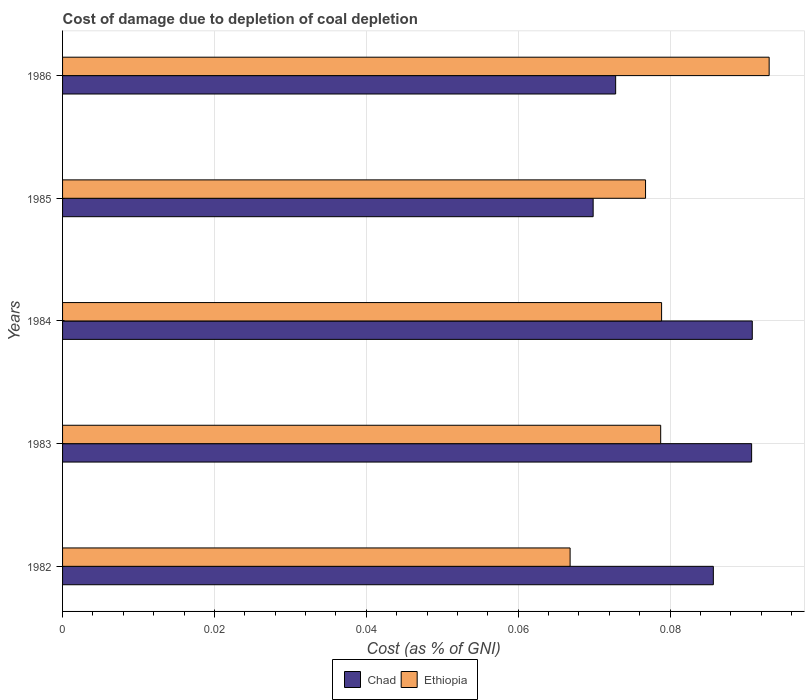How many groups of bars are there?
Keep it short and to the point. 5. Are the number of bars on each tick of the Y-axis equal?
Provide a short and direct response. Yes. How many bars are there on the 5th tick from the top?
Give a very brief answer. 2. How many bars are there on the 3rd tick from the bottom?
Provide a short and direct response. 2. In how many cases, is the number of bars for a given year not equal to the number of legend labels?
Ensure brevity in your answer.  0. What is the cost of damage caused due to coal depletion in Ethiopia in 1984?
Provide a succinct answer. 0.08. Across all years, what is the maximum cost of damage caused due to coal depletion in Ethiopia?
Ensure brevity in your answer.  0.09. Across all years, what is the minimum cost of damage caused due to coal depletion in Ethiopia?
Provide a short and direct response. 0.07. In which year was the cost of damage caused due to coal depletion in Ethiopia minimum?
Your answer should be compact. 1982. What is the total cost of damage caused due to coal depletion in Ethiopia in the graph?
Your response must be concise. 0.39. What is the difference between the cost of damage caused due to coal depletion in Chad in 1983 and that in 1985?
Ensure brevity in your answer.  0.02. What is the difference between the cost of damage caused due to coal depletion in Ethiopia in 1985 and the cost of damage caused due to coal depletion in Chad in 1983?
Offer a terse response. -0.01. What is the average cost of damage caused due to coal depletion in Ethiopia per year?
Offer a terse response. 0.08. In the year 1985, what is the difference between the cost of damage caused due to coal depletion in Ethiopia and cost of damage caused due to coal depletion in Chad?
Your answer should be very brief. 0.01. What is the ratio of the cost of damage caused due to coal depletion in Chad in 1983 to that in 1986?
Give a very brief answer. 1.25. Is the cost of damage caused due to coal depletion in Ethiopia in 1984 less than that in 1986?
Keep it short and to the point. Yes. What is the difference between the highest and the second highest cost of damage caused due to coal depletion in Ethiopia?
Offer a terse response. 0.01. What is the difference between the highest and the lowest cost of damage caused due to coal depletion in Ethiopia?
Make the answer very short. 0.03. In how many years, is the cost of damage caused due to coal depletion in Ethiopia greater than the average cost of damage caused due to coal depletion in Ethiopia taken over all years?
Give a very brief answer. 2. Is the sum of the cost of damage caused due to coal depletion in Ethiopia in 1983 and 1986 greater than the maximum cost of damage caused due to coal depletion in Chad across all years?
Ensure brevity in your answer.  Yes. What does the 1st bar from the top in 1983 represents?
Your response must be concise. Ethiopia. What does the 1st bar from the bottom in 1983 represents?
Keep it short and to the point. Chad. How many bars are there?
Offer a terse response. 10. Are all the bars in the graph horizontal?
Offer a terse response. Yes. What is the difference between two consecutive major ticks on the X-axis?
Provide a short and direct response. 0.02. Are the values on the major ticks of X-axis written in scientific E-notation?
Keep it short and to the point. No. Does the graph contain any zero values?
Ensure brevity in your answer.  No. What is the title of the graph?
Keep it short and to the point. Cost of damage due to depletion of coal depletion. Does "United Arab Emirates" appear as one of the legend labels in the graph?
Your response must be concise. No. What is the label or title of the X-axis?
Your answer should be very brief. Cost (as % of GNI). What is the Cost (as % of GNI) of Chad in 1982?
Your answer should be very brief. 0.09. What is the Cost (as % of GNI) in Ethiopia in 1982?
Give a very brief answer. 0.07. What is the Cost (as % of GNI) of Chad in 1983?
Your answer should be very brief. 0.09. What is the Cost (as % of GNI) in Ethiopia in 1983?
Provide a succinct answer. 0.08. What is the Cost (as % of GNI) in Chad in 1984?
Provide a succinct answer. 0.09. What is the Cost (as % of GNI) in Ethiopia in 1984?
Offer a terse response. 0.08. What is the Cost (as % of GNI) in Chad in 1985?
Give a very brief answer. 0.07. What is the Cost (as % of GNI) in Ethiopia in 1985?
Ensure brevity in your answer.  0.08. What is the Cost (as % of GNI) in Chad in 1986?
Offer a very short reply. 0.07. What is the Cost (as % of GNI) in Ethiopia in 1986?
Offer a very short reply. 0.09. Across all years, what is the maximum Cost (as % of GNI) in Chad?
Give a very brief answer. 0.09. Across all years, what is the maximum Cost (as % of GNI) in Ethiopia?
Make the answer very short. 0.09. Across all years, what is the minimum Cost (as % of GNI) of Chad?
Make the answer very short. 0.07. Across all years, what is the minimum Cost (as % of GNI) of Ethiopia?
Ensure brevity in your answer.  0.07. What is the total Cost (as % of GNI) in Chad in the graph?
Give a very brief answer. 0.41. What is the total Cost (as % of GNI) in Ethiopia in the graph?
Provide a succinct answer. 0.39. What is the difference between the Cost (as % of GNI) in Chad in 1982 and that in 1983?
Offer a terse response. -0.01. What is the difference between the Cost (as % of GNI) in Ethiopia in 1982 and that in 1983?
Provide a succinct answer. -0.01. What is the difference between the Cost (as % of GNI) of Chad in 1982 and that in 1984?
Your answer should be very brief. -0.01. What is the difference between the Cost (as % of GNI) in Ethiopia in 1982 and that in 1984?
Your answer should be compact. -0.01. What is the difference between the Cost (as % of GNI) of Chad in 1982 and that in 1985?
Offer a terse response. 0.02. What is the difference between the Cost (as % of GNI) of Ethiopia in 1982 and that in 1985?
Keep it short and to the point. -0.01. What is the difference between the Cost (as % of GNI) of Chad in 1982 and that in 1986?
Keep it short and to the point. 0.01. What is the difference between the Cost (as % of GNI) of Ethiopia in 1982 and that in 1986?
Your response must be concise. -0.03. What is the difference between the Cost (as % of GNI) of Chad in 1983 and that in 1984?
Offer a terse response. -0. What is the difference between the Cost (as % of GNI) of Ethiopia in 1983 and that in 1984?
Your response must be concise. -0. What is the difference between the Cost (as % of GNI) in Chad in 1983 and that in 1985?
Your answer should be compact. 0.02. What is the difference between the Cost (as % of GNI) of Ethiopia in 1983 and that in 1985?
Your answer should be compact. 0. What is the difference between the Cost (as % of GNI) in Chad in 1983 and that in 1986?
Provide a succinct answer. 0.02. What is the difference between the Cost (as % of GNI) in Ethiopia in 1983 and that in 1986?
Provide a succinct answer. -0.01. What is the difference between the Cost (as % of GNI) in Chad in 1984 and that in 1985?
Provide a short and direct response. 0.02. What is the difference between the Cost (as % of GNI) in Ethiopia in 1984 and that in 1985?
Offer a terse response. 0. What is the difference between the Cost (as % of GNI) in Chad in 1984 and that in 1986?
Your response must be concise. 0.02. What is the difference between the Cost (as % of GNI) of Ethiopia in 1984 and that in 1986?
Your answer should be very brief. -0.01. What is the difference between the Cost (as % of GNI) of Chad in 1985 and that in 1986?
Your response must be concise. -0. What is the difference between the Cost (as % of GNI) of Ethiopia in 1985 and that in 1986?
Offer a terse response. -0.02. What is the difference between the Cost (as % of GNI) in Chad in 1982 and the Cost (as % of GNI) in Ethiopia in 1983?
Give a very brief answer. 0.01. What is the difference between the Cost (as % of GNI) of Chad in 1982 and the Cost (as % of GNI) of Ethiopia in 1984?
Provide a short and direct response. 0.01. What is the difference between the Cost (as % of GNI) of Chad in 1982 and the Cost (as % of GNI) of Ethiopia in 1985?
Your response must be concise. 0.01. What is the difference between the Cost (as % of GNI) in Chad in 1982 and the Cost (as % of GNI) in Ethiopia in 1986?
Make the answer very short. -0.01. What is the difference between the Cost (as % of GNI) in Chad in 1983 and the Cost (as % of GNI) in Ethiopia in 1984?
Provide a short and direct response. 0.01. What is the difference between the Cost (as % of GNI) of Chad in 1983 and the Cost (as % of GNI) of Ethiopia in 1985?
Your answer should be compact. 0.01. What is the difference between the Cost (as % of GNI) in Chad in 1983 and the Cost (as % of GNI) in Ethiopia in 1986?
Provide a succinct answer. -0. What is the difference between the Cost (as % of GNI) in Chad in 1984 and the Cost (as % of GNI) in Ethiopia in 1985?
Ensure brevity in your answer.  0.01. What is the difference between the Cost (as % of GNI) of Chad in 1984 and the Cost (as % of GNI) of Ethiopia in 1986?
Make the answer very short. -0. What is the difference between the Cost (as % of GNI) of Chad in 1985 and the Cost (as % of GNI) of Ethiopia in 1986?
Make the answer very short. -0.02. What is the average Cost (as % of GNI) of Chad per year?
Your answer should be very brief. 0.08. What is the average Cost (as % of GNI) in Ethiopia per year?
Keep it short and to the point. 0.08. In the year 1982, what is the difference between the Cost (as % of GNI) in Chad and Cost (as % of GNI) in Ethiopia?
Your answer should be very brief. 0.02. In the year 1983, what is the difference between the Cost (as % of GNI) in Chad and Cost (as % of GNI) in Ethiopia?
Offer a terse response. 0.01. In the year 1984, what is the difference between the Cost (as % of GNI) in Chad and Cost (as % of GNI) in Ethiopia?
Provide a short and direct response. 0.01. In the year 1985, what is the difference between the Cost (as % of GNI) in Chad and Cost (as % of GNI) in Ethiopia?
Your response must be concise. -0.01. In the year 1986, what is the difference between the Cost (as % of GNI) in Chad and Cost (as % of GNI) in Ethiopia?
Make the answer very short. -0.02. What is the ratio of the Cost (as % of GNI) in Chad in 1982 to that in 1983?
Your answer should be very brief. 0.94. What is the ratio of the Cost (as % of GNI) in Ethiopia in 1982 to that in 1983?
Your answer should be very brief. 0.85. What is the ratio of the Cost (as % of GNI) of Chad in 1982 to that in 1984?
Make the answer very short. 0.94. What is the ratio of the Cost (as % of GNI) of Ethiopia in 1982 to that in 1984?
Your answer should be very brief. 0.85. What is the ratio of the Cost (as % of GNI) of Chad in 1982 to that in 1985?
Make the answer very short. 1.23. What is the ratio of the Cost (as % of GNI) of Ethiopia in 1982 to that in 1985?
Give a very brief answer. 0.87. What is the ratio of the Cost (as % of GNI) of Chad in 1982 to that in 1986?
Offer a very short reply. 1.18. What is the ratio of the Cost (as % of GNI) in Ethiopia in 1982 to that in 1986?
Your answer should be very brief. 0.72. What is the ratio of the Cost (as % of GNI) in Chad in 1983 to that in 1985?
Keep it short and to the point. 1.3. What is the ratio of the Cost (as % of GNI) of Ethiopia in 1983 to that in 1985?
Give a very brief answer. 1.03. What is the ratio of the Cost (as % of GNI) in Chad in 1983 to that in 1986?
Your answer should be compact. 1.25. What is the ratio of the Cost (as % of GNI) in Ethiopia in 1983 to that in 1986?
Your response must be concise. 0.85. What is the ratio of the Cost (as % of GNI) of Chad in 1984 to that in 1985?
Your answer should be compact. 1.3. What is the ratio of the Cost (as % of GNI) in Ethiopia in 1984 to that in 1985?
Your answer should be compact. 1.03. What is the ratio of the Cost (as % of GNI) in Chad in 1984 to that in 1986?
Your answer should be compact. 1.25. What is the ratio of the Cost (as % of GNI) of Ethiopia in 1984 to that in 1986?
Your answer should be compact. 0.85. What is the ratio of the Cost (as % of GNI) of Chad in 1985 to that in 1986?
Make the answer very short. 0.96. What is the ratio of the Cost (as % of GNI) of Ethiopia in 1985 to that in 1986?
Your response must be concise. 0.83. What is the difference between the highest and the second highest Cost (as % of GNI) in Ethiopia?
Ensure brevity in your answer.  0.01. What is the difference between the highest and the lowest Cost (as % of GNI) of Chad?
Give a very brief answer. 0.02. What is the difference between the highest and the lowest Cost (as % of GNI) in Ethiopia?
Provide a short and direct response. 0.03. 